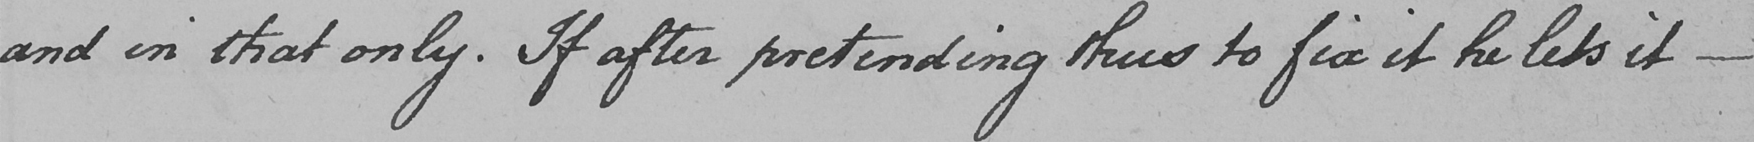Transcribe the text shown in this historical manuscript line. and in that only . If after pretending thus to fix it he lets it  _ 